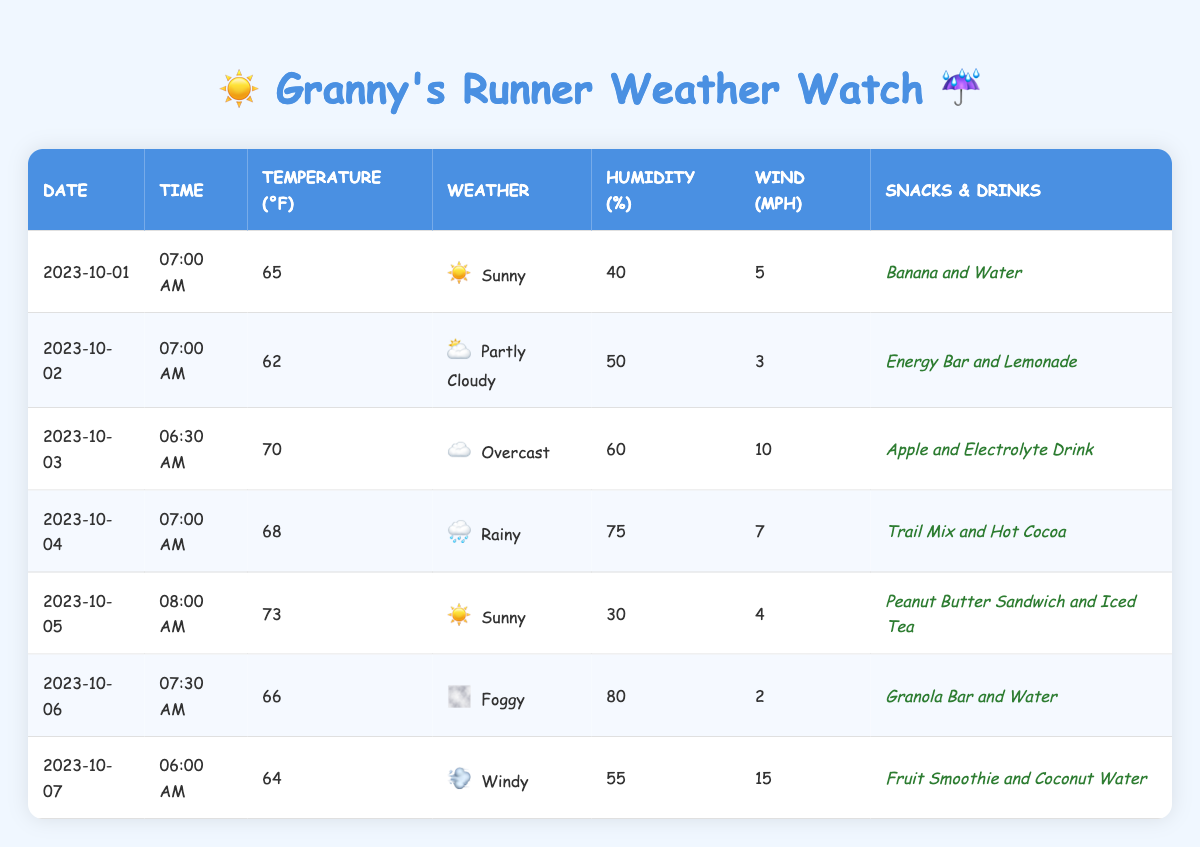What was the weather condition on October 4th? The table shows the data for October 4th with a weather condition listed as "Rainy."
Answer: Rainy What was the highest temperature recorded during the training sessions? By looking at the temperature values in the table (65, 62, 70, 68, 73, 66, 64), the highest is 73°F on October 5th.
Answer: 73°F What snacks were provided during the foggy weather? The table indicates that on October 6th, which had foggy weather, the nutrition provided was "Granola Bar and Water."
Answer: Granola Bar and Water How many training sessions had a humidity level above 60%? Reviewing the humidity levels (40, 50, 60, 75, 30, 80, 55), three values are above 60%: 75% (October 4), 60% (October 3), and 80% (October 6). Hence, there are three sessions.
Answer: 3 What was the average wind speed during the training sessions? The wind speeds listed are 5, 3, 10, 7, 4, 2, and 15 mph. Adding these together gives a total of 46 mph, divided by the 7 sessions results in an average wind speed of approximately 6.57 mph.
Answer: 6.57 mph Is there any day where the temperature was below 65°F? On reviewing the temperatures, October 2nd shows 62°F and October 1st shows 65°F. Thus, October 2nd had a temperature below 65°F, making the statement true.
Answer: Yes On which dates was a peanut butter sandwich provided? The table shows that a peanut butter sandwich was provided on October 5th, during sunny weather.
Answer: October 5 What was the total humidity recorded on the days with sunny weather? The sunny weather occurred on October 1 and October 5, with humidity values of 40% and 30%, respectively. Adding these yields a total humidity of 70%.
Answer: 70% Which date had the lowest wind speed, and what was that speed? Reviewing the wind speeds, October 6 had the lowest speed of 2 mph while being foggy.
Answer: 2 mph Was there a training session on October 3rd? The table confirms that there was indeed a training session on October 3rd, with details provided in the record.
Answer: Yes 